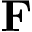<formula> <loc_0><loc_0><loc_500><loc_500>F</formula> 